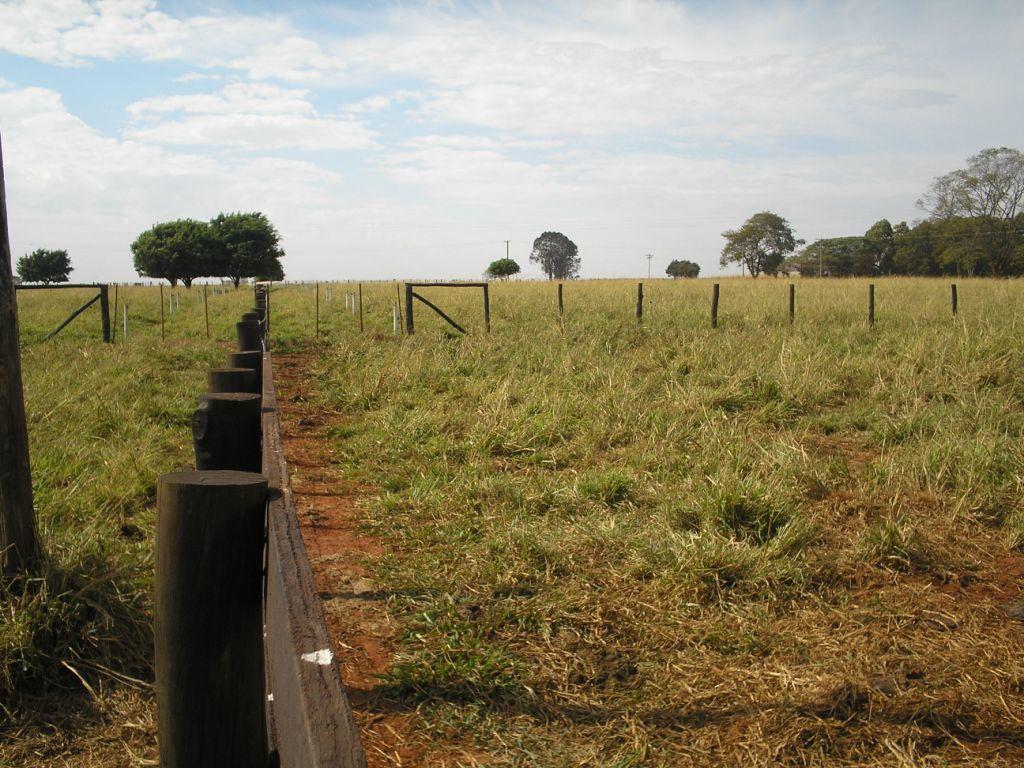In one or two sentences, can you explain what this image depicts? This image contains grassland having fence on it. Left side there is wooden fence. Middle of image there are few trees. Top of image there is sky with some clouds. 